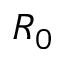<formula> <loc_0><loc_0><loc_500><loc_500>R _ { 0 }</formula> 